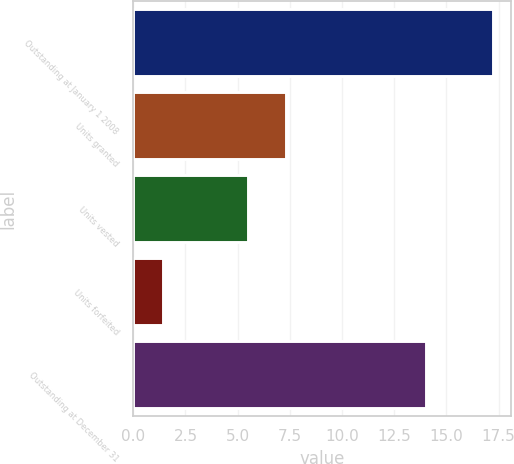Convert chart to OTSL. <chart><loc_0><loc_0><loc_500><loc_500><bar_chart><fcel>Outstanding at January 1 2008<fcel>Units granted<fcel>Units vested<fcel>Units forfeited<fcel>Outstanding at December 31<nl><fcel>17.23<fcel>7.3<fcel>5.5<fcel>1.4<fcel>14<nl></chart> 